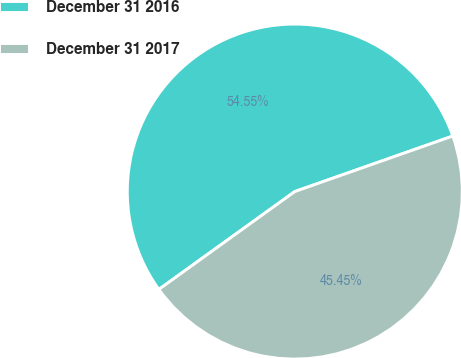<chart> <loc_0><loc_0><loc_500><loc_500><pie_chart><fcel>December 31 2016<fcel>December 31 2017<nl><fcel>54.55%<fcel>45.45%<nl></chart> 